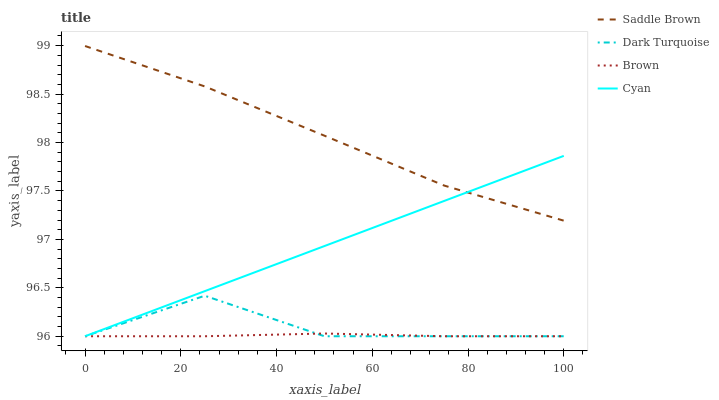Does Brown have the minimum area under the curve?
Answer yes or no. Yes. Does Saddle Brown have the maximum area under the curve?
Answer yes or no. Yes. Does Cyan have the minimum area under the curve?
Answer yes or no. No. Does Cyan have the maximum area under the curve?
Answer yes or no. No. Is Cyan the smoothest?
Answer yes or no. Yes. Is Dark Turquoise the roughest?
Answer yes or no. Yes. Is Saddle Brown the smoothest?
Answer yes or no. No. Is Saddle Brown the roughest?
Answer yes or no. No. Does Dark Turquoise have the lowest value?
Answer yes or no. Yes. Does Saddle Brown have the lowest value?
Answer yes or no. No. Does Saddle Brown have the highest value?
Answer yes or no. Yes. Does Cyan have the highest value?
Answer yes or no. No. Is Brown less than Saddle Brown?
Answer yes or no. Yes. Is Saddle Brown greater than Dark Turquoise?
Answer yes or no. Yes. Does Saddle Brown intersect Cyan?
Answer yes or no. Yes. Is Saddle Brown less than Cyan?
Answer yes or no. No. Is Saddle Brown greater than Cyan?
Answer yes or no. No. Does Brown intersect Saddle Brown?
Answer yes or no. No. 